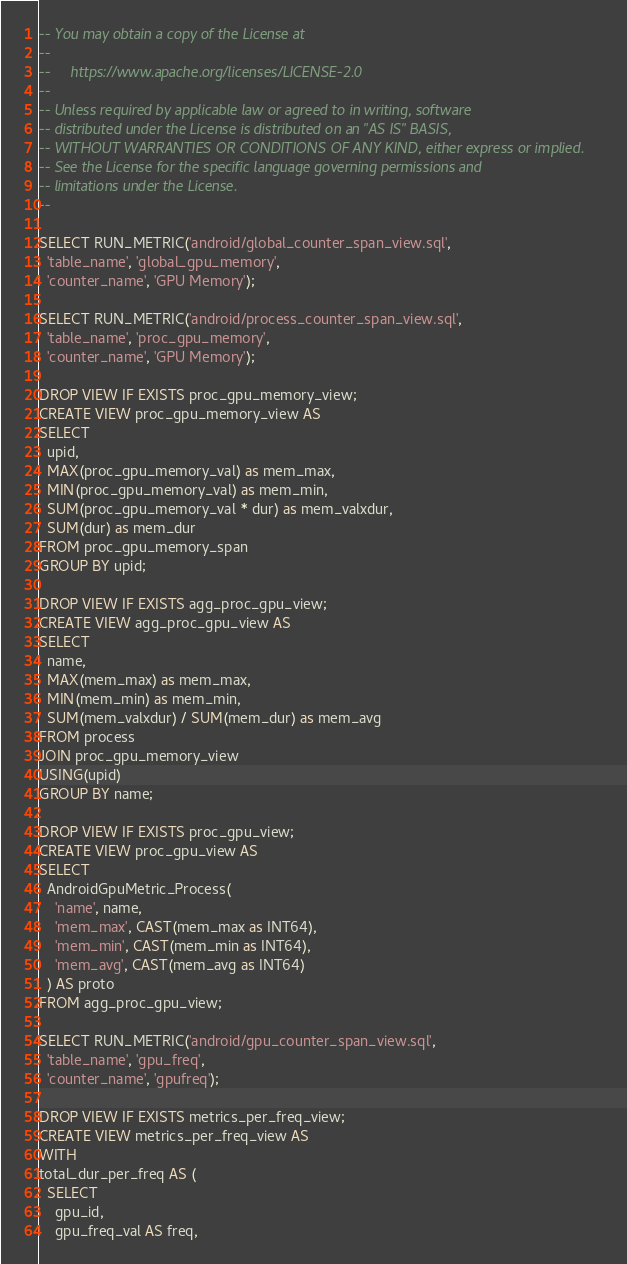<code> <loc_0><loc_0><loc_500><loc_500><_SQL_>-- You may obtain a copy of the License at
--
--     https://www.apache.org/licenses/LICENSE-2.0
--
-- Unless required by applicable law or agreed to in writing, software
-- distributed under the License is distributed on an "AS IS" BASIS,
-- WITHOUT WARRANTIES OR CONDITIONS OF ANY KIND, either express or implied.
-- See the License for the specific language governing permissions and
-- limitations under the License.
--

SELECT RUN_METRIC('android/global_counter_span_view.sql',
  'table_name', 'global_gpu_memory',
  'counter_name', 'GPU Memory');

SELECT RUN_METRIC('android/process_counter_span_view.sql',
  'table_name', 'proc_gpu_memory',
  'counter_name', 'GPU Memory');

DROP VIEW IF EXISTS proc_gpu_memory_view;
CREATE VIEW proc_gpu_memory_view AS
SELECT
  upid,
  MAX(proc_gpu_memory_val) as mem_max,
  MIN(proc_gpu_memory_val) as mem_min,
  SUM(proc_gpu_memory_val * dur) as mem_valxdur,
  SUM(dur) as mem_dur
FROM proc_gpu_memory_span
GROUP BY upid;

DROP VIEW IF EXISTS agg_proc_gpu_view;
CREATE VIEW agg_proc_gpu_view AS
SELECT
  name,
  MAX(mem_max) as mem_max,
  MIN(mem_min) as mem_min,
  SUM(mem_valxdur) / SUM(mem_dur) as mem_avg
FROM process
JOIN proc_gpu_memory_view
USING(upid)
GROUP BY name;

DROP VIEW IF EXISTS proc_gpu_view;
CREATE VIEW proc_gpu_view AS
SELECT
  AndroidGpuMetric_Process(
    'name', name,
    'mem_max', CAST(mem_max as INT64),
    'mem_min', CAST(mem_min as INT64),
    'mem_avg', CAST(mem_avg as INT64)
  ) AS proto
FROM agg_proc_gpu_view;

SELECT RUN_METRIC('android/gpu_counter_span_view.sql',
  'table_name', 'gpu_freq',
  'counter_name', 'gpufreq');

DROP VIEW IF EXISTS metrics_per_freq_view;
CREATE VIEW metrics_per_freq_view AS
WITH
total_dur_per_freq AS (
  SELECT
    gpu_id,
    gpu_freq_val AS freq,</code> 